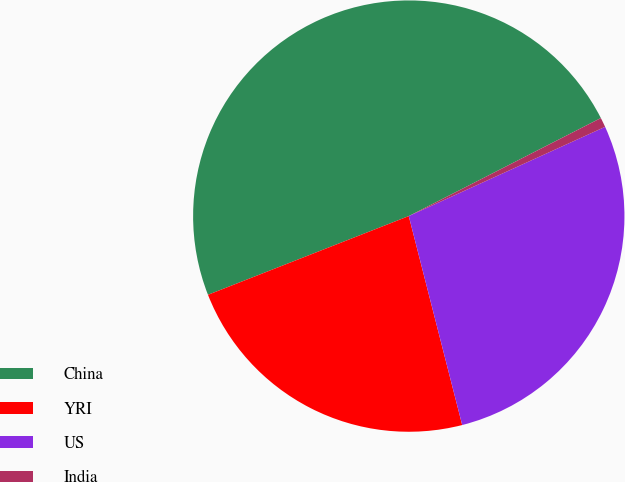<chart> <loc_0><loc_0><loc_500><loc_500><pie_chart><fcel>China<fcel>YRI<fcel>US<fcel>India<nl><fcel>48.44%<fcel>23.04%<fcel>27.81%<fcel>0.72%<nl></chart> 